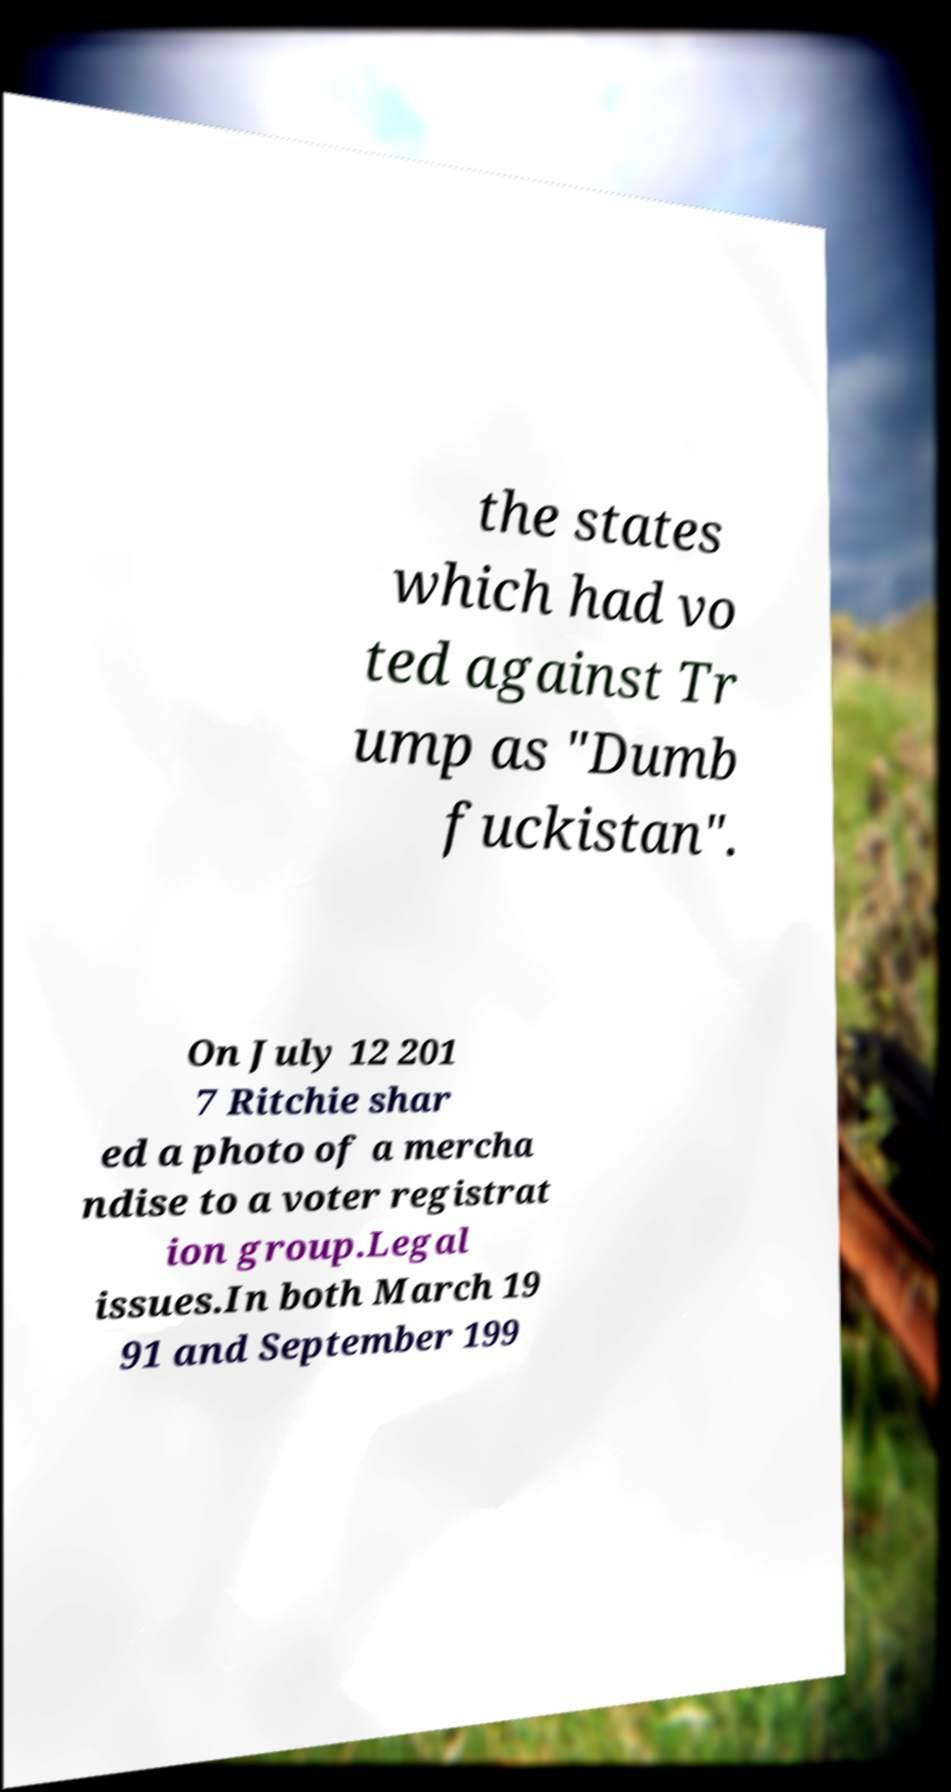I need the written content from this picture converted into text. Can you do that? the states which had vo ted against Tr ump as "Dumb fuckistan". On July 12 201 7 Ritchie shar ed a photo of a mercha ndise to a voter registrat ion group.Legal issues.In both March 19 91 and September 199 